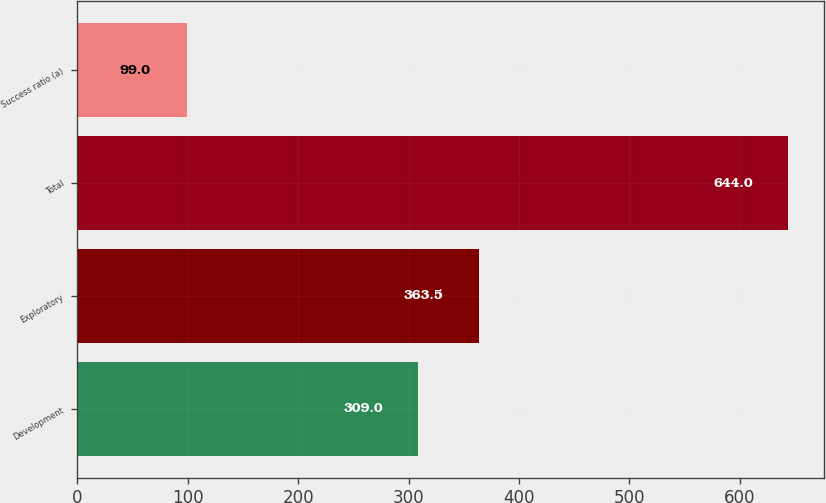Convert chart. <chart><loc_0><loc_0><loc_500><loc_500><bar_chart><fcel>Development<fcel>Exploratory<fcel>Total<fcel>Success ratio (a)<nl><fcel>309<fcel>363.5<fcel>644<fcel>99<nl></chart> 